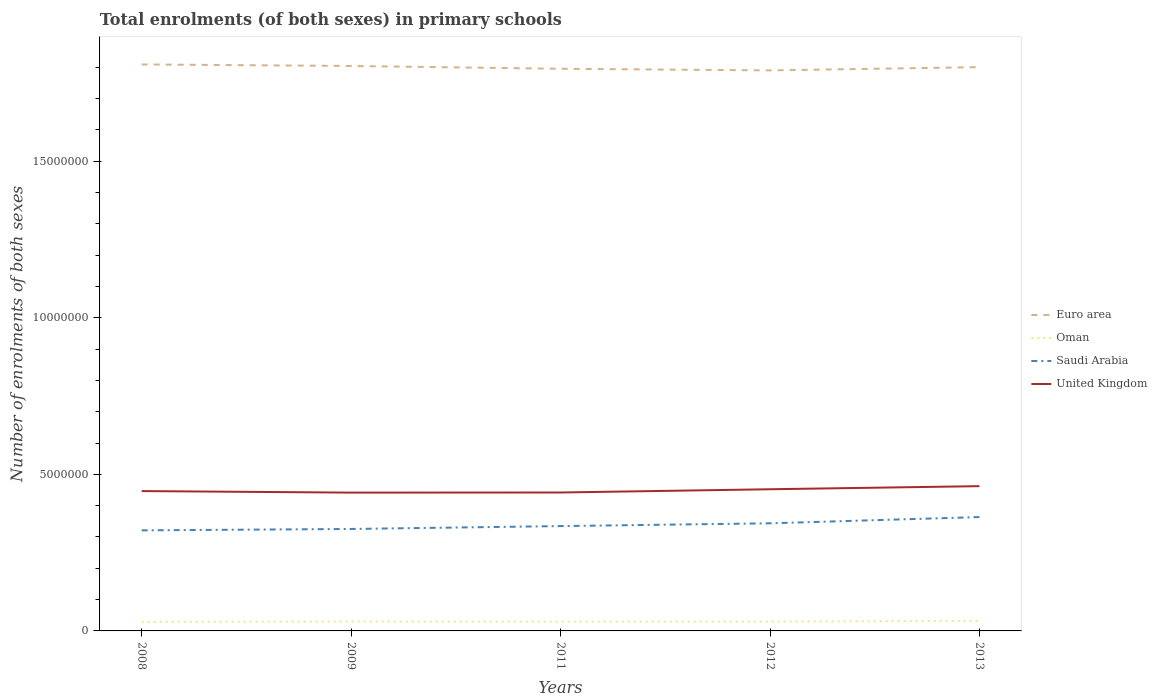How many different coloured lines are there?
Give a very brief answer. 4. Does the line corresponding to Euro area intersect with the line corresponding to Saudi Arabia?
Keep it short and to the point. No. Is the number of lines equal to the number of legend labels?
Make the answer very short. Yes. Across all years, what is the maximum number of enrolments in primary schools in Saudi Arabia?
Provide a succinct answer. 3.21e+06. What is the total number of enrolments in primary schools in Oman in the graph?
Provide a short and direct response. -1.83e+04. What is the difference between the highest and the second highest number of enrolments in primary schools in Oman?
Your answer should be compact. 3.06e+04. What is the difference between the highest and the lowest number of enrolments in primary schools in Oman?
Keep it short and to the point. 2. Is the number of enrolments in primary schools in United Kingdom strictly greater than the number of enrolments in primary schools in Euro area over the years?
Ensure brevity in your answer.  Yes. How many years are there in the graph?
Ensure brevity in your answer.  5. What is the difference between two consecutive major ticks on the Y-axis?
Your answer should be very brief. 5.00e+06. Does the graph contain any zero values?
Keep it short and to the point. No. How are the legend labels stacked?
Give a very brief answer. Vertical. What is the title of the graph?
Your response must be concise. Total enrolments (of both sexes) in primary schools. Does "Lower middle income" appear as one of the legend labels in the graph?
Your answer should be very brief. No. What is the label or title of the Y-axis?
Your answer should be very brief. Number of enrolments of both sexes. What is the Number of enrolments of both sexes of Euro area in 2008?
Your answer should be compact. 1.81e+07. What is the Number of enrolments of both sexes of Oman in 2008?
Keep it short and to the point. 2.90e+05. What is the Number of enrolments of both sexes of Saudi Arabia in 2008?
Keep it short and to the point. 3.21e+06. What is the Number of enrolments of both sexes in United Kingdom in 2008?
Provide a short and direct response. 4.47e+06. What is the Number of enrolments of both sexes in Euro area in 2009?
Keep it short and to the point. 1.80e+07. What is the Number of enrolments of both sexes in Oman in 2009?
Ensure brevity in your answer.  3.02e+05. What is the Number of enrolments of both sexes in Saudi Arabia in 2009?
Offer a terse response. 3.26e+06. What is the Number of enrolments of both sexes in United Kingdom in 2009?
Offer a terse response. 4.42e+06. What is the Number of enrolments of both sexes in Euro area in 2011?
Provide a succinct answer. 1.79e+07. What is the Number of enrolments of both sexes in Oman in 2011?
Make the answer very short. 2.96e+05. What is the Number of enrolments of both sexes in Saudi Arabia in 2011?
Ensure brevity in your answer.  3.35e+06. What is the Number of enrolments of both sexes in United Kingdom in 2011?
Your answer should be very brief. 4.42e+06. What is the Number of enrolments of both sexes of Euro area in 2012?
Your response must be concise. 1.79e+07. What is the Number of enrolments of both sexes in Oman in 2012?
Provide a short and direct response. 2.99e+05. What is the Number of enrolments of both sexes in Saudi Arabia in 2012?
Provide a succinct answer. 3.44e+06. What is the Number of enrolments of both sexes in United Kingdom in 2012?
Give a very brief answer. 4.52e+06. What is the Number of enrolments of both sexes of Euro area in 2013?
Provide a succinct answer. 1.80e+07. What is the Number of enrolments of both sexes in Oman in 2013?
Make the answer very short. 3.20e+05. What is the Number of enrolments of both sexes of Saudi Arabia in 2013?
Make the answer very short. 3.64e+06. What is the Number of enrolments of both sexes of United Kingdom in 2013?
Provide a short and direct response. 4.62e+06. Across all years, what is the maximum Number of enrolments of both sexes of Euro area?
Your answer should be very brief. 1.81e+07. Across all years, what is the maximum Number of enrolments of both sexes of Oman?
Offer a terse response. 3.20e+05. Across all years, what is the maximum Number of enrolments of both sexes in Saudi Arabia?
Your answer should be very brief. 3.64e+06. Across all years, what is the maximum Number of enrolments of both sexes of United Kingdom?
Your answer should be compact. 4.62e+06. Across all years, what is the minimum Number of enrolments of both sexes in Euro area?
Ensure brevity in your answer.  1.79e+07. Across all years, what is the minimum Number of enrolments of both sexes in Oman?
Give a very brief answer. 2.90e+05. Across all years, what is the minimum Number of enrolments of both sexes of Saudi Arabia?
Ensure brevity in your answer.  3.21e+06. Across all years, what is the minimum Number of enrolments of both sexes in United Kingdom?
Your answer should be very brief. 4.42e+06. What is the total Number of enrolments of both sexes of Euro area in the graph?
Your answer should be very brief. 9.00e+07. What is the total Number of enrolments of both sexes of Oman in the graph?
Offer a very short reply. 1.51e+06. What is the total Number of enrolments of both sexes in Saudi Arabia in the graph?
Ensure brevity in your answer.  1.69e+07. What is the total Number of enrolments of both sexes in United Kingdom in the graph?
Offer a terse response. 2.24e+07. What is the difference between the Number of enrolments of both sexes of Euro area in 2008 and that in 2009?
Provide a short and direct response. 4.85e+04. What is the difference between the Number of enrolments of both sexes in Oman in 2008 and that in 2009?
Your response must be concise. -1.23e+04. What is the difference between the Number of enrolments of both sexes of Saudi Arabia in 2008 and that in 2009?
Keep it short and to the point. -4.39e+04. What is the difference between the Number of enrolments of both sexes in United Kingdom in 2008 and that in 2009?
Offer a terse response. 4.85e+04. What is the difference between the Number of enrolments of both sexes in Euro area in 2008 and that in 2011?
Give a very brief answer. 1.38e+05. What is the difference between the Number of enrolments of both sexes in Oman in 2008 and that in 2011?
Provide a succinct answer. -5864. What is the difference between the Number of enrolments of both sexes in Saudi Arabia in 2008 and that in 2011?
Your answer should be very brief. -1.36e+05. What is the difference between the Number of enrolments of both sexes of United Kingdom in 2008 and that in 2011?
Offer a terse response. 4.52e+04. What is the difference between the Number of enrolments of both sexes in Euro area in 2008 and that in 2012?
Your answer should be very brief. 1.90e+05. What is the difference between the Number of enrolments of both sexes in Oman in 2008 and that in 2012?
Your answer should be very brief. -9754. What is the difference between the Number of enrolments of both sexes of Saudi Arabia in 2008 and that in 2012?
Your answer should be very brief. -2.25e+05. What is the difference between the Number of enrolments of both sexes of United Kingdom in 2008 and that in 2012?
Offer a very short reply. -5.86e+04. What is the difference between the Number of enrolments of both sexes of Euro area in 2008 and that in 2013?
Ensure brevity in your answer.  8.60e+04. What is the difference between the Number of enrolments of both sexes in Oman in 2008 and that in 2013?
Provide a short and direct response. -3.06e+04. What is the difference between the Number of enrolments of both sexes in Saudi Arabia in 2008 and that in 2013?
Offer a terse response. -4.24e+05. What is the difference between the Number of enrolments of both sexes of United Kingdom in 2008 and that in 2013?
Give a very brief answer. -1.57e+05. What is the difference between the Number of enrolments of both sexes in Euro area in 2009 and that in 2011?
Keep it short and to the point. 8.98e+04. What is the difference between the Number of enrolments of both sexes of Oman in 2009 and that in 2011?
Give a very brief answer. 6456. What is the difference between the Number of enrolments of both sexes of Saudi Arabia in 2009 and that in 2011?
Your answer should be very brief. -9.24e+04. What is the difference between the Number of enrolments of both sexes of United Kingdom in 2009 and that in 2011?
Your response must be concise. -3366. What is the difference between the Number of enrolments of both sexes of Euro area in 2009 and that in 2012?
Provide a succinct answer. 1.41e+05. What is the difference between the Number of enrolments of both sexes in Oman in 2009 and that in 2012?
Your answer should be compact. 2566. What is the difference between the Number of enrolments of both sexes of Saudi Arabia in 2009 and that in 2012?
Make the answer very short. -1.81e+05. What is the difference between the Number of enrolments of both sexes in United Kingdom in 2009 and that in 2012?
Your answer should be compact. -1.07e+05. What is the difference between the Number of enrolments of both sexes of Euro area in 2009 and that in 2013?
Keep it short and to the point. 3.75e+04. What is the difference between the Number of enrolments of both sexes of Oman in 2009 and that in 2013?
Ensure brevity in your answer.  -1.83e+04. What is the difference between the Number of enrolments of both sexes of Saudi Arabia in 2009 and that in 2013?
Offer a very short reply. -3.81e+05. What is the difference between the Number of enrolments of both sexes in United Kingdom in 2009 and that in 2013?
Offer a terse response. -2.06e+05. What is the difference between the Number of enrolments of both sexes in Euro area in 2011 and that in 2012?
Offer a terse response. 5.12e+04. What is the difference between the Number of enrolments of both sexes of Oman in 2011 and that in 2012?
Your answer should be very brief. -3890. What is the difference between the Number of enrolments of both sexes of Saudi Arabia in 2011 and that in 2012?
Ensure brevity in your answer.  -8.86e+04. What is the difference between the Number of enrolments of both sexes in United Kingdom in 2011 and that in 2012?
Provide a succinct answer. -1.04e+05. What is the difference between the Number of enrolments of both sexes in Euro area in 2011 and that in 2013?
Your response must be concise. -5.23e+04. What is the difference between the Number of enrolments of both sexes of Oman in 2011 and that in 2013?
Offer a very short reply. -2.47e+04. What is the difference between the Number of enrolments of both sexes in Saudi Arabia in 2011 and that in 2013?
Provide a succinct answer. -2.88e+05. What is the difference between the Number of enrolments of both sexes of United Kingdom in 2011 and that in 2013?
Make the answer very short. -2.02e+05. What is the difference between the Number of enrolments of both sexes of Euro area in 2012 and that in 2013?
Your answer should be very brief. -1.04e+05. What is the difference between the Number of enrolments of both sexes in Oman in 2012 and that in 2013?
Make the answer very short. -2.09e+04. What is the difference between the Number of enrolments of both sexes in Saudi Arabia in 2012 and that in 2013?
Offer a very short reply. -2.00e+05. What is the difference between the Number of enrolments of both sexes of United Kingdom in 2012 and that in 2013?
Provide a succinct answer. -9.86e+04. What is the difference between the Number of enrolments of both sexes in Euro area in 2008 and the Number of enrolments of both sexes in Oman in 2009?
Your response must be concise. 1.78e+07. What is the difference between the Number of enrolments of both sexes of Euro area in 2008 and the Number of enrolments of both sexes of Saudi Arabia in 2009?
Keep it short and to the point. 1.48e+07. What is the difference between the Number of enrolments of both sexes of Euro area in 2008 and the Number of enrolments of both sexes of United Kingdom in 2009?
Offer a very short reply. 1.37e+07. What is the difference between the Number of enrolments of both sexes of Oman in 2008 and the Number of enrolments of both sexes of Saudi Arabia in 2009?
Provide a short and direct response. -2.97e+06. What is the difference between the Number of enrolments of both sexes of Oman in 2008 and the Number of enrolments of both sexes of United Kingdom in 2009?
Your answer should be very brief. -4.13e+06. What is the difference between the Number of enrolments of both sexes in Saudi Arabia in 2008 and the Number of enrolments of both sexes in United Kingdom in 2009?
Your answer should be very brief. -1.21e+06. What is the difference between the Number of enrolments of both sexes of Euro area in 2008 and the Number of enrolments of both sexes of Oman in 2011?
Keep it short and to the point. 1.78e+07. What is the difference between the Number of enrolments of both sexes of Euro area in 2008 and the Number of enrolments of both sexes of Saudi Arabia in 2011?
Your response must be concise. 1.47e+07. What is the difference between the Number of enrolments of both sexes in Euro area in 2008 and the Number of enrolments of both sexes in United Kingdom in 2011?
Offer a very short reply. 1.37e+07. What is the difference between the Number of enrolments of both sexes of Oman in 2008 and the Number of enrolments of both sexes of Saudi Arabia in 2011?
Keep it short and to the point. -3.06e+06. What is the difference between the Number of enrolments of both sexes of Oman in 2008 and the Number of enrolments of both sexes of United Kingdom in 2011?
Provide a short and direct response. -4.13e+06. What is the difference between the Number of enrolments of both sexes of Saudi Arabia in 2008 and the Number of enrolments of both sexes of United Kingdom in 2011?
Provide a short and direct response. -1.21e+06. What is the difference between the Number of enrolments of both sexes of Euro area in 2008 and the Number of enrolments of both sexes of Oman in 2012?
Your answer should be compact. 1.78e+07. What is the difference between the Number of enrolments of both sexes in Euro area in 2008 and the Number of enrolments of both sexes in Saudi Arabia in 2012?
Give a very brief answer. 1.47e+07. What is the difference between the Number of enrolments of both sexes in Euro area in 2008 and the Number of enrolments of both sexes in United Kingdom in 2012?
Provide a short and direct response. 1.36e+07. What is the difference between the Number of enrolments of both sexes of Oman in 2008 and the Number of enrolments of both sexes of Saudi Arabia in 2012?
Your response must be concise. -3.15e+06. What is the difference between the Number of enrolments of both sexes of Oman in 2008 and the Number of enrolments of both sexes of United Kingdom in 2012?
Your response must be concise. -4.23e+06. What is the difference between the Number of enrolments of both sexes of Saudi Arabia in 2008 and the Number of enrolments of both sexes of United Kingdom in 2012?
Your answer should be compact. -1.31e+06. What is the difference between the Number of enrolments of both sexes in Euro area in 2008 and the Number of enrolments of both sexes in Oman in 2013?
Make the answer very short. 1.78e+07. What is the difference between the Number of enrolments of both sexes in Euro area in 2008 and the Number of enrolments of both sexes in Saudi Arabia in 2013?
Your answer should be very brief. 1.45e+07. What is the difference between the Number of enrolments of both sexes in Euro area in 2008 and the Number of enrolments of both sexes in United Kingdom in 2013?
Make the answer very short. 1.35e+07. What is the difference between the Number of enrolments of both sexes of Oman in 2008 and the Number of enrolments of both sexes of Saudi Arabia in 2013?
Provide a short and direct response. -3.35e+06. What is the difference between the Number of enrolments of both sexes of Oman in 2008 and the Number of enrolments of both sexes of United Kingdom in 2013?
Make the answer very short. -4.33e+06. What is the difference between the Number of enrolments of both sexes of Saudi Arabia in 2008 and the Number of enrolments of both sexes of United Kingdom in 2013?
Provide a short and direct response. -1.41e+06. What is the difference between the Number of enrolments of both sexes in Euro area in 2009 and the Number of enrolments of both sexes in Oman in 2011?
Your response must be concise. 1.77e+07. What is the difference between the Number of enrolments of both sexes of Euro area in 2009 and the Number of enrolments of both sexes of Saudi Arabia in 2011?
Your answer should be compact. 1.47e+07. What is the difference between the Number of enrolments of both sexes of Euro area in 2009 and the Number of enrolments of both sexes of United Kingdom in 2011?
Your response must be concise. 1.36e+07. What is the difference between the Number of enrolments of both sexes of Oman in 2009 and the Number of enrolments of both sexes of Saudi Arabia in 2011?
Make the answer very short. -3.05e+06. What is the difference between the Number of enrolments of both sexes in Oman in 2009 and the Number of enrolments of both sexes in United Kingdom in 2011?
Offer a terse response. -4.12e+06. What is the difference between the Number of enrolments of both sexes in Saudi Arabia in 2009 and the Number of enrolments of both sexes in United Kingdom in 2011?
Offer a terse response. -1.16e+06. What is the difference between the Number of enrolments of both sexes in Euro area in 2009 and the Number of enrolments of both sexes in Oman in 2012?
Offer a terse response. 1.77e+07. What is the difference between the Number of enrolments of both sexes of Euro area in 2009 and the Number of enrolments of both sexes of Saudi Arabia in 2012?
Provide a short and direct response. 1.46e+07. What is the difference between the Number of enrolments of both sexes in Euro area in 2009 and the Number of enrolments of both sexes in United Kingdom in 2012?
Offer a terse response. 1.35e+07. What is the difference between the Number of enrolments of both sexes of Oman in 2009 and the Number of enrolments of both sexes of Saudi Arabia in 2012?
Provide a succinct answer. -3.13e+06. What is the difference between the Number of enrolments of both sexes of Oman in 2009 and the Number of enrolments of both sexes of United Kingdom in 2012?
Offer a terse response. -4.22e+06. What is the difference between the Number of enrolments of both sexes in Saudi Arabia in 2009 and the Number of enrolments of both sexes in United Kingdom in 2012?
Your answer should be compact. -1.27e+06. What is the difference between the Number of enrolments of both sexes in Euro area in 2009 and the Number of enrolments of both sexes in Oman in 2013?
Make the answer very short. 1.77e+07. What is the difference between the Number of enrolments of both sexes in Euro area in 2009 and the Number of enrolments of both sexes in Saudi Arabia in 2013?
Offer a terse response. 1.44e+07. What is the difference between the Number of enrolments of both sexes in Euro area in 2009 and the Number of enrolments of both sexes in United Kingdom in 2013?
Provide a succinct answer. 1.34e+07. What is the difference between the Number of enrolments of both sexes of Oman in 2009 and the Number of enrolments of both sexes of Saudi Arabia in 2013?
Ensure brevity in your answer.  -3.33e+06. What is the difference between the Number of enrolments of both sexes of Oman in 2009 and the Number of enrolments of both sexes of United Kingdom in 2013?
Your response must be concise. -4.32e+06. What is the difference between the Number of enrolments of both sexes in Saudi Arabia in 2009 and the Number of enrolments of both sexes in United Kingdom in 2013?
Make the answer very short. -1.37e+06. What is the difference between the Number of enrolments of both sexes in Euro area in 2011 and the Number of enrolments of both sexes in Oman in 2012?
Offer a terse response. 1.76e+07. What is the difference between the Number of enrolments of both sexes of Euro area in 2011 and the Number of enrolments of both sexes of Saudi Arabia in 2012?
Ensure brevity in your answer.  1.45e+07. What is the difference between the Number of enrolments of both sexes in Euro area in 2011 and the Number of enrolments of both sexes in United Kingdom in 2012?
Give a very brief answer. 1.34e+07. What is the difference between the Number of enrolments of both sexes in Oman in 2011 and the Number of enrolments of both sexes in Saudi Arabia in 2012?
Give a very brief answer. -3.14e+06. What is the difference between the Number of enrolments of both sexes of Oman in 2011 and the Number of enrolments of both sexes of United Kingdom in 2012?
Make the answer very short. -4.23e+06. What is the difference between the Number of enrolments of both sexes in Saudi Arabia in 2011 and the Number of enrolments of both sexes in United Kingdom in 2012?
Your answer should be very brief. -1.18e+06. What is the difference between the Number of enrolments of both sexes of Euro area in 2011 and the Number of enrolments of both sexes of Oman in 2013?
Provide a succinct answer. 1.76e+07. What is the difference between the Number of enrolments of both sexes of Euro area in 2011 and the Number of enrolments of both sexes of Saudi Arabia in 2013?
Offer a terse response. 1.43e+07. What is the difference between the Number of enrolments of both sexes of Euro area in 2011 and the Number of enrolments of both sexes of United Kingdom in 2013?
Offer a very short reply. 1.33e+07. What is the difference between the Number of enrolments of both sexes of Oman in 2011 and the Number of enrolments of both sexes of Saudi Arabia in 2013?
Your answer should be compact. -3.34e+06. What is the difference between the Number of enrolments of both sexes of Oman in 2011 and the Number of enrolments of both sexes of United Kingdom in 2013?
Make the answer very short. -4.33e+06. What is the difference between the Number of enrolments of both sexes of Saudi Arabia in 2011 and the Number of enrolments of both sexes of United Kingdom in 2013?
Offer a very short reply. -1.27e+06. What is the difference between the Number of enrolments of both sexes in Euro area in 2012 and the Number of enrolments of both sexes in Oman in 2013?
Provide a succinct answer. 1.76e+07. What is the difference between the Number of enrolments of both sexes of Euro area in 2012 and the Number of enrolments of both sexes of Saudi Arabia in 2013?
Offer a very short reply. 1.43e+07. What is the difference between the Number of enrolments of both sexes of Euro area in 2012 and the Number of enrolments of both sexes of United Kingdom in 2013?
Ensure brevity in your answer.  1.33e+07. What is the difference between the Number of enrolments of both sexes in Oman in 2012 and the Number of enrolments of both sexes in Saudi Arabia in 2013?
Your answer should be very brief. -3.34e+06. What is the difference between the Number of enrolments of both sexes of Oman in 2012 and the Number of enrolments of both sexes of United Kingdom in 2013?
Ensure brevity in your answer.  -4.32e+06. What is the difference between the Number of enrolments of both sexes of Saudi Arabia in 2012 and the Number of enrolments of both sexes of United Kingdom in 2013?
Keep it short and to the point. -1.19e+06. What is the average Number of enrolments of both sexes of Euro area per year?
Ensure brevity in your answer.  1.80e+07. What is the average Number of enrolments of both sexes in Oman per year?
Keep it short and to the point. 3.01e+05. What is the average Number of enrolments of both sexes in Saudi Arabia per year?
Keep it short and to the point. 3.38e+06. What is the average Number of enrolments of both sexes in United Kingdom per year?
Provide a short and direct response. 4.49e+06. In the year 2008, what is the difference between the Number of enrolments of both sexes in Euro area and Number of enrolments of both sexes in Oman?
Provide a short and direct response. 1.78e+07. In the year 2008, what is the difference between the Number of enrolments of both sexes in Euro area and Number of enrolments of both sexes in Saudi Arabia?
Make the answer very short. 1.49e+07. In the year 2008, what is the difference between the Number of enrolments of both sexes in Euro area and Number of enrolments of both sexes in United Kingdom?
Give a very brief answer. 1.36e+07. In the year 2008, what is the difference between the Number of enrolments of both sexes in Oman and Number of enrolments of both sexes in Saudi Arabia?
Your response must be concise. -2.92e+06. In the year 2008, what is the difference between the Number of enrolments of both sexes of Oman and Number of enrolments of both sexes of United Kingdom?
Provide a short and direct response. -4.18e+06. In the year 2008, what is the difference between the Number of enrolments of both sexes in Saudi Arabia and Number of enrolments of both sexes in United Kingdom?
Make the answer very short. -1.25e+06. In the year 2009, what is the difference between the Number of enrolments of both sexes of Euro area and Number of enrolments of both sexes of Oman?
Your answer should be compact. 1.77e+07. In the year 2009, what is the difference between the Number of enrolments of both sexes in Euro area and Number of enrolments of both sexes in Saudi Arabia?
Ensure brevity in your answer.  1.48e+07. In the year 2009, what is the difference between the Number of enrolments of both sexes of Euro area and Number of enrolments of both sexes of United Kingdom?
Your response must be concise. 1.36e+07. In the year 2009, what is the difference between the Number of enrolments of both sexes in Oman and Number of enrolments of both sexes in Saudi Arabia?
Your response must be concise. -2.95e+06. In the year 2009, what is the difference between the Number of enrolments of both sexes of Oman and Number of enrolments of both sexes of United Kingdom?
Provide a succinct answer. -4.11e+06. In the year 2009, what is the difference between the Number of enrolments of both sexes in Saudi Arabia and Number of enrolments of both sexes in United Kingdom?
Offer a terse response. -1.16e+06. In the year 2011, what is the difference between the Number of enrolments of both sexes in Euro area and Number of enrolments of both sexes in Oman?
Ensure brevity in your answer.  1.77e+07. In the year 2011, what is the difference between the Number of enrolments of both sexes in Euro area and Number of enrolments of both sexes in Saudi Arabia?
Provide a short and direct response. 1.46e+07. In the year 2011, what is the difference between the Number of enrolments of both sexes of Euro area and Number of enrolments of both sexes of United Kingdom?
Offer a terse response. 1.35e+07. In the year 2011, what is the difference between the Number of enrolments of both sexes of Oman and Number of enrolments of both sexes of Saudi Arabia?
Keep it short and to the point. -3.05e+06. In the year 2011, what is the difference between the Number of enrolments of both sexes of Oman and Number of enrolments of both sexes of United Kingdom?
Keep it short and to the point. -4.12e+06. In the year 2011, what is the difference between the Number of enrolments of both sexes of Saudi Arabia and Number of enrolments of both sexes of United Kingdom?
Give a very brief answer. -1.07e+06. In the year 2012, what is the difference between the Number of enrolments of both sexes of Euro area and Number of enrolments of both sexes of Oman?
Make the answer very short. 1.76e+07. In the year 2012, what is the difference between the Number of enrolments of both sexes in Euro area and Number of enrolments of both sexes in Saudi Arabia?
Offer a very short reply. 1.45e+07. In the year 2012, what is the difference between the Number of enrolments of both sexes of Euro area and Number of enrolments of both sexes of United Kingdom?
Provide a short and direct response. 1.34e+07. In the year 2012, what is the difference between the Number of enrolments of both sexes of Oman and Number of enrolments of both sexes of Saudi Arabia?
Ensure brevity in your answer.  -3.14e+06. In the year 2012, what is the difference between the Number of enrolments of both sexes of Oman and Number of enrolments of both sexes of United Kingdom?
Your answer should be compact. -4.22e+06. In the year 2012, what is the difference between the Number of enrolments of both sexes of Saudi Arabia and Number of enrolments of both sexes of United Kingdom?
Provide a succinct answer. -1.09e+06. In the year 2013, what is the difference between the Number of enrolments of both sexes of Euro area and Number of enrolments of both sexes of Oman?
Offer a very short reply. 1.77e+07. In the year 2013, what is the difference between the Number of enrolments of both sexes in Euro area and Number of enrolments of both sexes in Saudi Arabia?
Provide a succinct answer. 1.44e+07. In the year 2013, what is the difference between the Number of enrolments of both sexes of Euro area and Number of enrolments of both sexes of United Kingdom?
Your answer should be very brief. 1.34e+07. In the year 2013, what is the difference between the Number of enrolments of both sexes in Oman and Number of enrolments of both sexes in Saudi Arabia?
Offer a very short reply. -3.32e+06. In the year 2013, what is the difference between the Number of enrolments of both sexes of Oman and Number of enrolments of both sexes of United Kingdom?
Your response must be concise. -4.30e+06. In the year 2013, what is the difference between the Number of enrolments of both sexes of Saudi Arabia and Number of enrolments of both sexes of United Kingdom?
Provide a succinct answer. -9.86e+05. What is the ratio of the Number of enrolments of both sexes of Oman in 2008 to that in 2009?
Provide a succinct answer. 0.96. What is the ratio of the Number of enrolments of both sexes of Saudi Arabia in 2008 to that in 2009?
Ensure brevity in your answer.  0.99. What is the ratio of the Number of enrolments of both sexes in Euro area in 2008 to that in 2011?
Offer a very short reply. 1.01. What is the ratio of the Number of enrolments of both sexes in Oman in 2008 to that in 2011?
Keep it short and to the point. 0.98. What is the ratio of the Number of enrolments of both sexes of Saudi Arabia in 2008 to that in 2011?
Ensure brevity in your answer.  0.96. What is the ratio of the Number of enrolments of both sexes in United Kingdom in 2008 to that in 2011?
Offer a very short reply. 1.01. What is the ratio of the Number of enrolments of both sexes in Euro area in 2008 to that in 2012?
Keep it short and to the point. 1.01. What is the ratio of the Number of enrolments of both sexes of Oman in 2008 to that in 2012?
Your response must be concise. 0.97. What is the ratio of the Number of enrolments of both sexes in Saudi Arabia in 2008 to that in 2012?
Offer a terse response. 0.93. What is the ratio of the Number of enrolments of both sexes of United Kingdom in 2008 to that in 2012?
Give a very brief answer. 0.99. What is the ratio of the Number of enrolments of both sexes of Oman in 2008 to that in 2013?
Keep it short and to the point. 0.9. What is the ratio of the Number of enrolments of both sexes in Saudi Arabia in 2008 to that in 2013?
Offer a very short reply. 0.88. What is the ratio of the Number of enrolments of both sexes in Oman in 2009 to that in 2011?
Provide a short and direct response. 1.02. What is the ratio of the Number of enrolments of both sexes in Saudi Arabia in 2009 to that in 2011?
Your response must be concise. 0.97. What is the ratio of the Number of enrolments of both sexes of Euro area in 2009 to that in 2012?
Make the answer very short. 1.01. What is the ratio of the Number of enrolments of both sexes of Oman in 2009 to that in 2012?
Make the answer very short. 1.01. What is the ratio of the Number of enrolments of both sexes of Saudi Arabia in 2009 to that in 2012?
Offer a terse response. 0.95. What is the ratio of the Number of enrolments of both sexes in United Kingdom in 2009 to that in 2012?
Ensure brevity in your answer.  0.98. What is the ratio of the Number of enrolments of both sexes in Euro area in 2009 to that in 2013?
Your answer should be very brief. 1. What is the ratio of the Number of enrolments of both sexes in Oman in 2009 to that in 2013?
Offer a terse response. 0.94. What is the ratio of the Number of enrolments of both sexes in Saudi Arabia in 2009 to that in 2013?
Make the answer very short. 0.9. What is the ratio of the Number of enrolments of both sexes in United Kingdom in 2009 to that in 2013?
Offer a very short reply. 0.96. What is the ratio of the Number of enrolments of both sexes in Euro area in 2011 to that in 2012?
Offer a terse response. 1. What is the ratio of the Number of enrolments of both sexes in Saudi Arabia in 2011 to that in 2012?
Give a very brief answer. 0.97. What is the ratio of the Number of enrolments of both sexes in United Kingdom in 2011 to that in 2012?
Offer a terse response. 0.98. What is the ratio of the Number of enrolments of both sexes of Euro area in 2011 to that in 2013?
Provide a short and direct response. 1. What is the ratio of the Number of enrolments of both sexes in Oman in 2011 to that in 2013?
Provide a short and direct response. 0.92. What is the ratio of the Number of enrolments of both sexes in Saudi Arabia in 2011 to that in 2013?
Ensure brevity in your answer.  0.92. What is the ratio of the Number of enrolments of both sexes in United Kingdom in 2011 to that in 2013?
Keep it short and to the point. 0.96. What is the ratio of the Number of enrolments of both sexes of Euro area in 2012 to that in 2013?
Offer a very short reply. 0.99. What is the ratio of the Number of enrolments of both sexes in Oman in 2012 to that in 2013?
Your answer should be compact. 0.93. What is the ratio of the Number of enrolments of both sexes in Saudi Arabia in 2012 to that in 2013?
Give a very brief answer. 0.95. What is the ratio of the Number of enrolments of both sexes in United Kingdom in 2012 to that in 2013?
Your answer should be compact. 0.98. What is the difference between the highest and the second highest Number of enrolments of both sexes of Euro area?
Ensure brevity in your answer.  4.85e+04. What is the difference between the highest and the second highest Number of enrolments of both sexes of Oman?
Your answer should be compact. 1.83e+04. What is the difference between the highest and the second highest Number of enrolments of both sexes of Saudi Arabia?
Your answer should be very brief. 2.00e+05. What is the difference between the highest and the second highest Number of enrolments of both sexes in United Kingdom?
Your answer should be compact. 9.86e+04. What is the difference between the highest and the lowest Number of enrolments of both sexes of Euro area?
Provide a short and direct response. 1.90e+05. What is the difference between the highest and the lowest Number of enrolments of both sexes in Oman?
Offer a terse response. 3.06e+04. What is the difference between the highest and the lowest Number of enrolments of both sexes in Saudi Arabia?
Ensure brevity in your answer.  4.24e+05. What is the difference between the highest and the lowest Number of enrolments of both sexes of United Kingdom?
Offer a very short reply. 2.06e+05. 